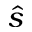Convert formula to latex. <formula><loc_0><loc_0><loc_500><loc_500>\hat { s }</formula> 